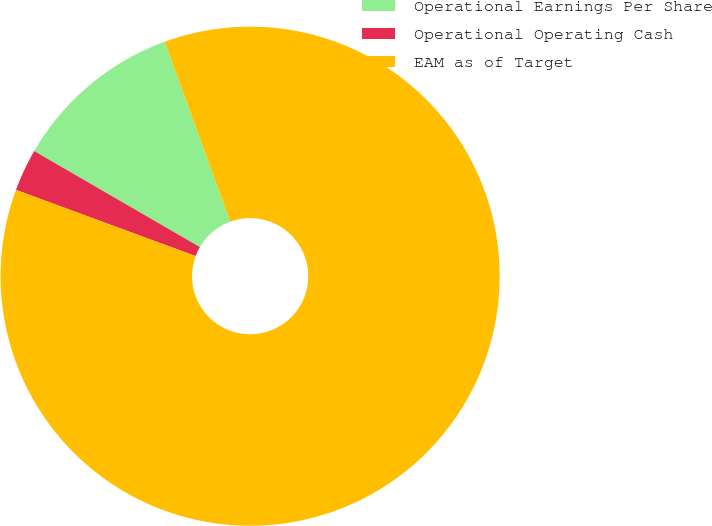<chart> <loc_0><loc_0><loc_500><loc_500><pie_chart><fcel>Operational Earnings Per Share<fcel>Operational Operating Cash<fcel>EAM as of Target<nl><fcel>11.08%<fcel>2.74%<fcel>86.18%<nl></chart> 